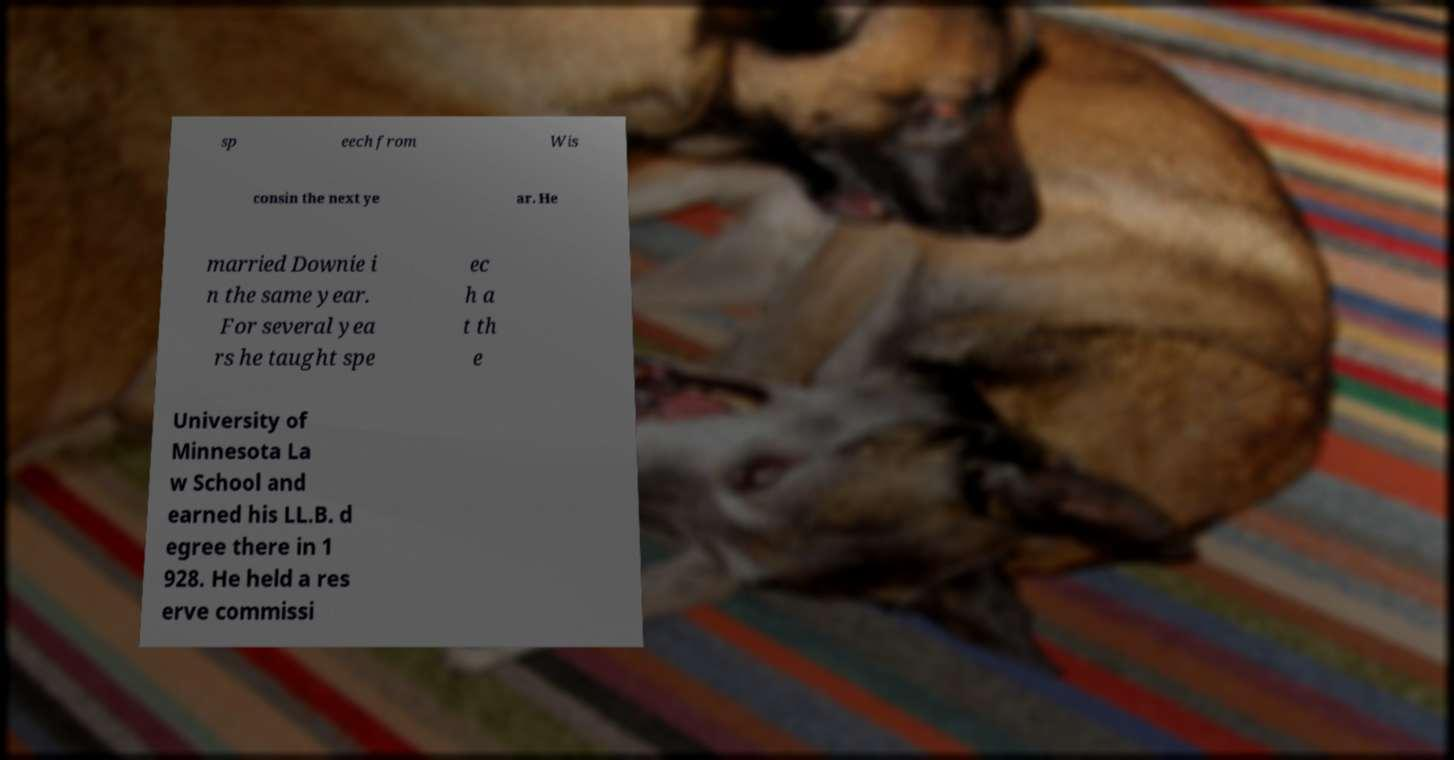Can you read and provide the text displayed in the image?This photo seems to have some interesting text. Can you extract and type it out for me? sp eech from Wis consin the next ye ar. He married Downie i n the same year. For several yea rs he taught spe ec h a t th e University of Minnesota La w School and earned his LL.B. d egree there in 1 928. He held a res erve commissi 